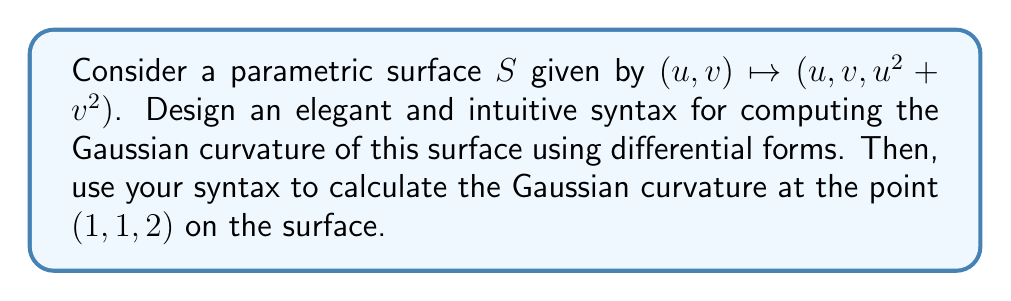Help me with this question. Let's design a syntax for computing Gaussian curvature using differential forms:

1. Define the surface:
```
surface S(u, v) = (u, v, u^2 + v^2)
```

2. Compute the first fundamental form:
```
E = du · du
F = du · dv
G = dv · dv
```

3. Compute the second fundamental form:
```
L = d^2S · N / |N|
M = d^2S · N / |N|
N = d^2S · N / |N|
```
where N is the unit normal vector and d^2S is the second differential.

4. Calculate Gaussian curvature:
```
K = (LN - M^2) / (EG - F^2)
```

Now, let's apply this syntax to our problem:

1. Surface definition:
```
S(u, v) = (u, v, u^2 + v^2)
```

2. First fundamental form:
```
E = du · du = 1
F = du · dv = 0
G = dv · dv = 1
```

3. Second fundamental form:
Calculate the normal vector:
$$N = \frac{\partial S}{\partial u} \times \frac{\partial S}{\partial v} = (1,0,2u) \times (0,1,2v) = (-2u, -2v, 1)$$

Normalize:
$$\hat{N} = \frac{(-2u, -2v, 1)}{\sqrt{4u^2 + 4v^2 + 1}}$$

Now compute L, M, and N:
$$L = \frac{\partial^2 S}{\partial u^2} \cdot \hat{N} = (0,0,2) \cdot \frac{(-2u, -2v, 1)}{\sqrt{4u^2 + 4v^2 + 1}} = \frac{2}{\sqrt{4u^2 + 4v^2 + 1}}$$

$$M = \frac{\partial^2 S}{\partial u \partial v} \cdot \hat{N} = (0,0,0) \cdot \hat{N} = 0$$

$$N = \frac{\partial^2 S}{\partial v^2} \cdot \hat{N} = (0,0,2) \cdot \frac{(-2u, -2v, 1)}{\sqrt{4u^2 + 4v^2 + 1}} = \frac{2}{\sqrt{4u^2 + 4v^2 + 1}}$$

4. Gaussian curvature:
$$K = \frac{LN - M^2}{EG - F^2} = \frac{(\frac{2}{\sqrt{4u^2 + 4v^2 + 1}})^2 - 0^2}{1 \cdot 1 - 0^2} = \frac{4}{4u^2 + 4v^2 + 1}$$

At the point (1,1,2), u = 1 and v = 1:
$$K_{(1,1,2)} = \frac{4}{4(1)^2 + 4(1)^2 + 1} = \frac{4}{9}$$
Answer: $K_{(1,1,2)} = \frac{4}{9}$ 